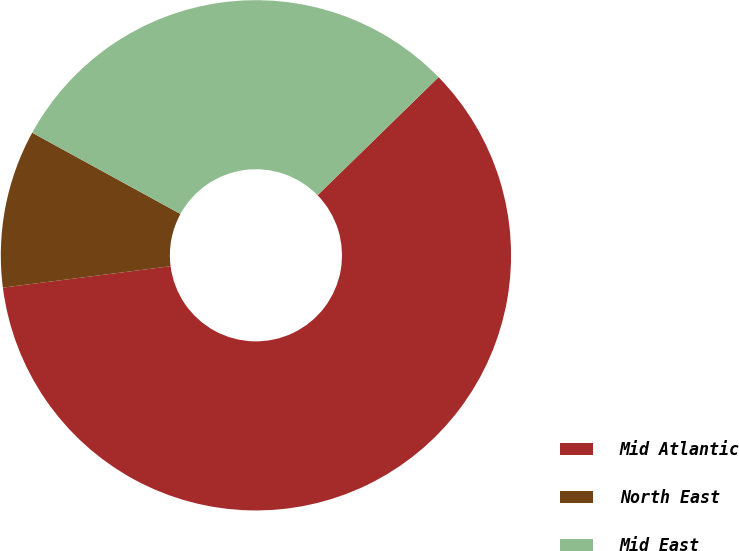<chart> <loc_0><loc_0><loc_500><loc_500><pie_chart><fcel>Mid Atlantic<fcel>North East<fcel>Mid East<nl><fcel>60.28%<fcel>10.0%<fcel>29.72%<nl></chart> 